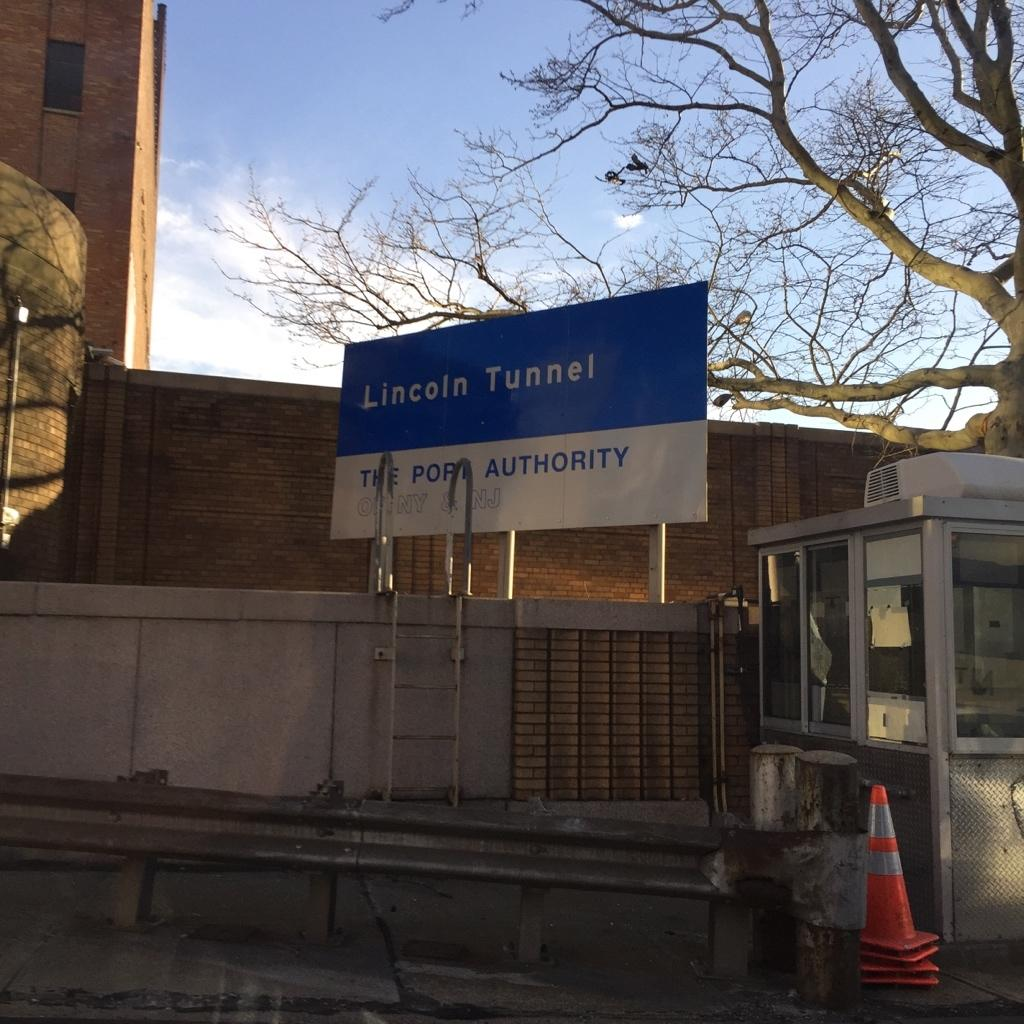What type of structure is visible in the image? There is a building in the image. What is written or displayed on the building? There is a name board on the building. What objects can be seen on the ground in the image? There are cones in the image. What type of vegetation is present in the image? There is a tree in the image. How would you describe the sky in the image? The sky is blue and cloudy in the image. How many zebras are visible in the image? There are no zebras present in the image. What type of rings can be seen on the tree in the image? There are no rings visible on the tree in the image. 